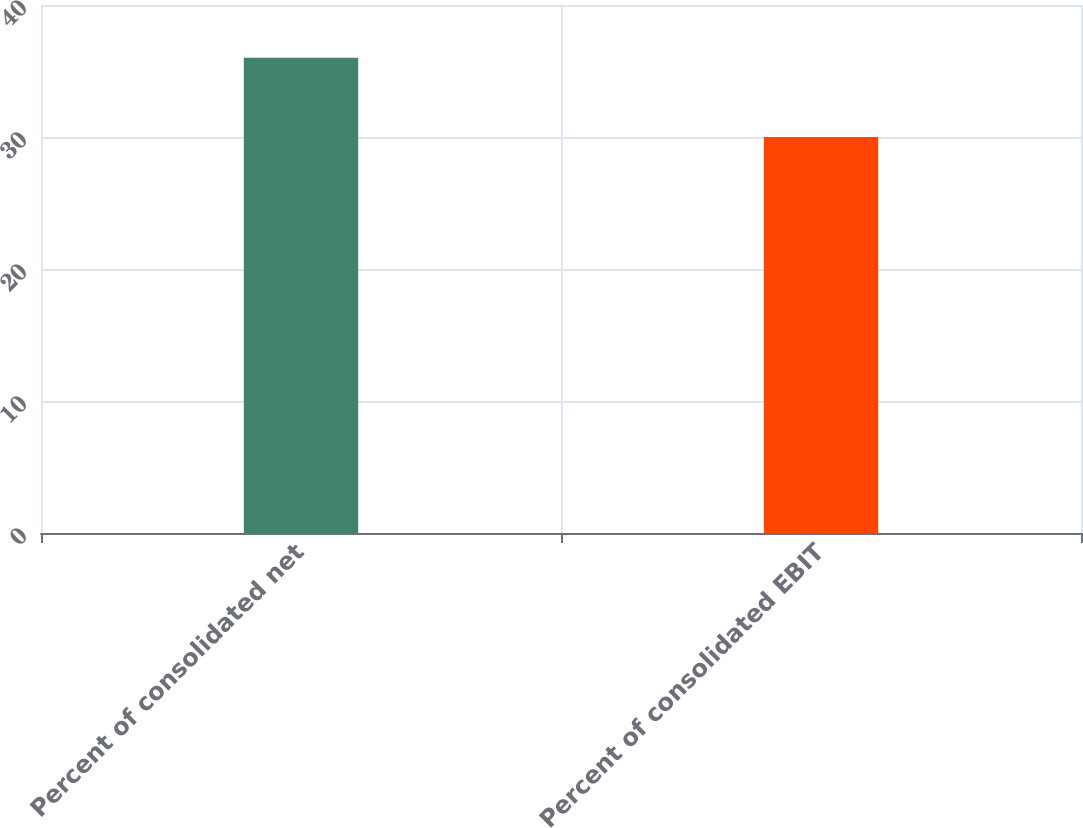Convert chart to OTSL. <chart><loc_0><loc_0><loc_500><loc_500><bar_chart><fcel>Percent of consolidated net<fcel>Percent of consolidated EBIT<nl><fcel>36<fcel>30<nl></chart> 